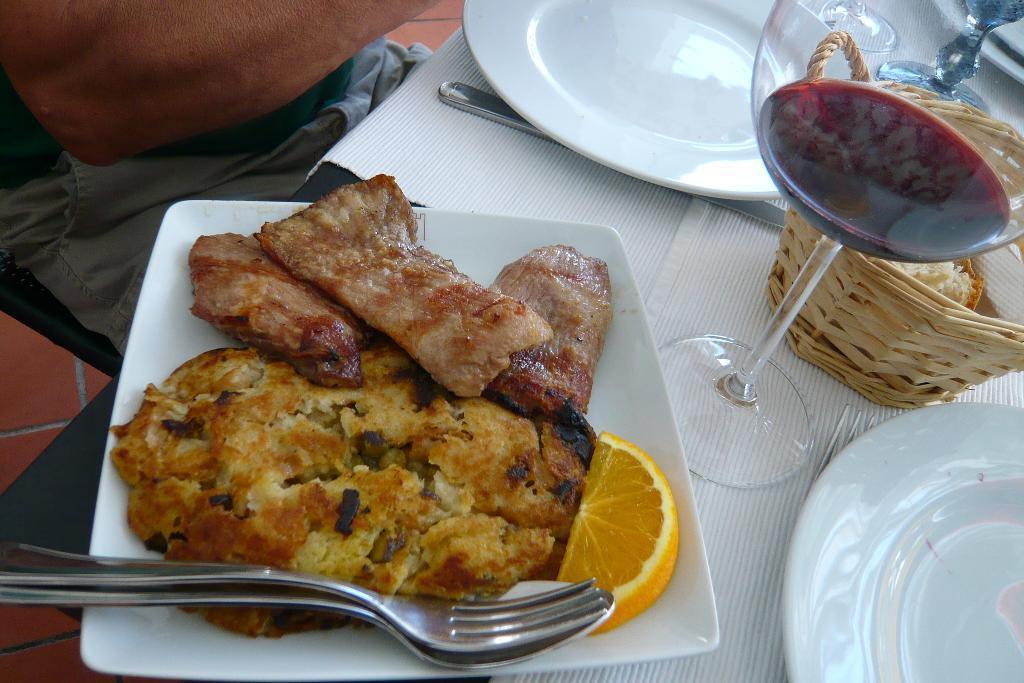In one or two sentences, can you explain what this image depicts? In this picture we can the partial part of a person sitting. We can see objects, basket, food, plates, knife, spoon, fork and table mats. We can see liquid in a glass. 